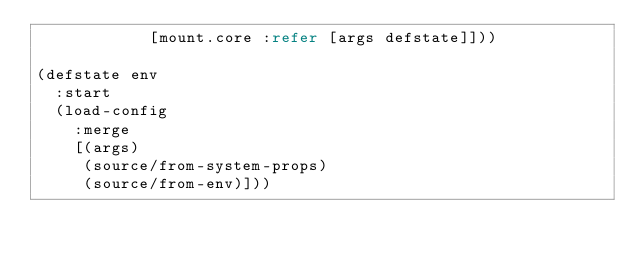Convert code to text. <code><loc_0><loc_0><loc_500><loc_500><_Clojure_>            [mount.core :refer [args defstate]]))

(defstate env
  :start
  (load-config
    :merge
    [(args)
     (source/from-system-props)
     (source/from-env)]))
</code> 